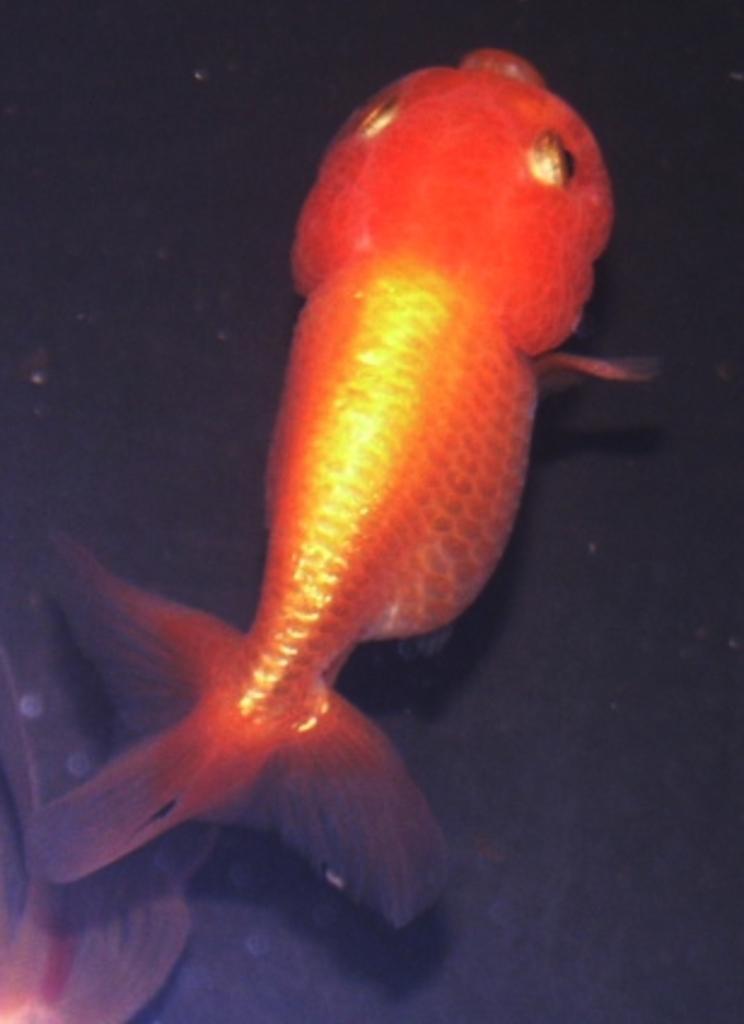Can you describe this image briefly? In this image we can see a fish and the background is dark in color. 